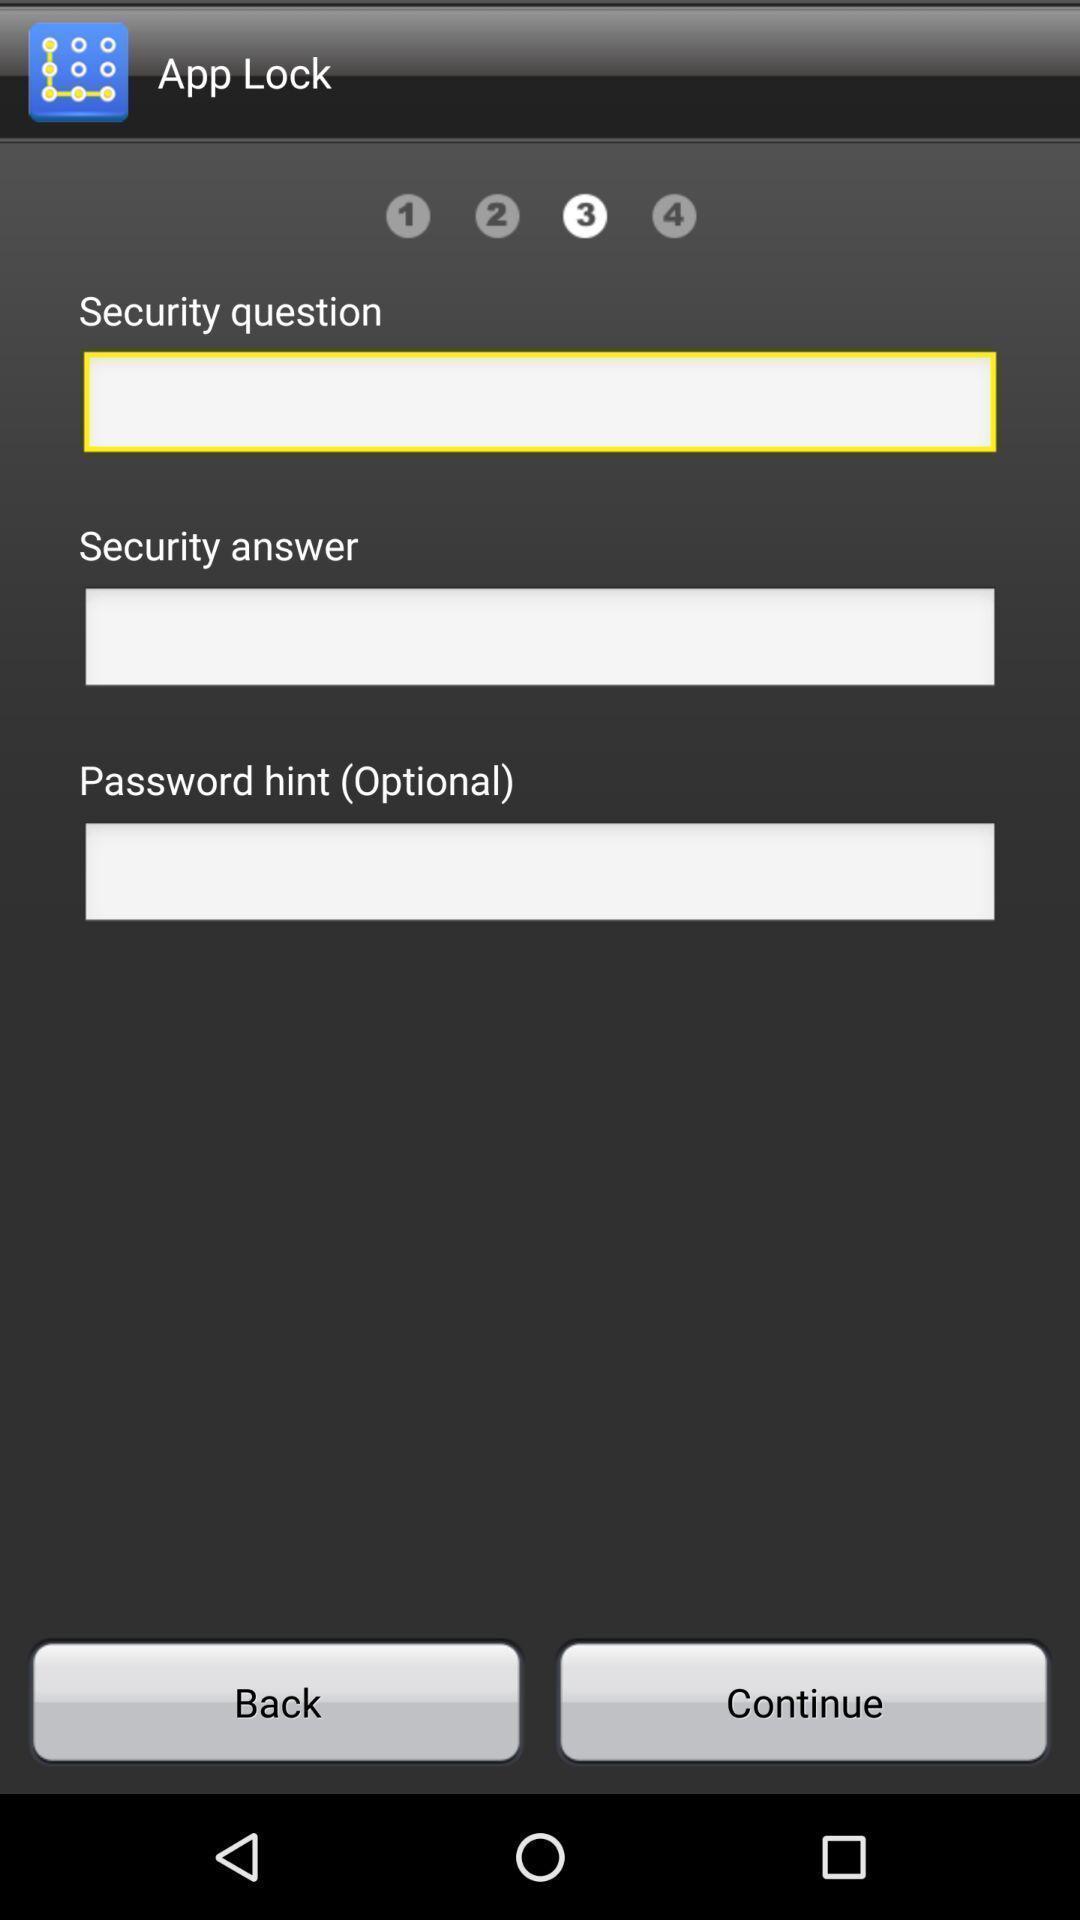Tell me what you see in this picture. Page for setting a password. 